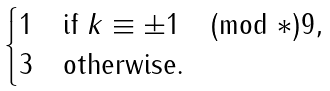Convert formula to latex. <formula><loc_0><loc_0><loc_500><loc_500>\begin{cases} 1 & \text {if } k \equiv \pm 1 \pmod { * } { 9 } , \\ 3 & \text {otherwise} . \end{cases}</formula> 